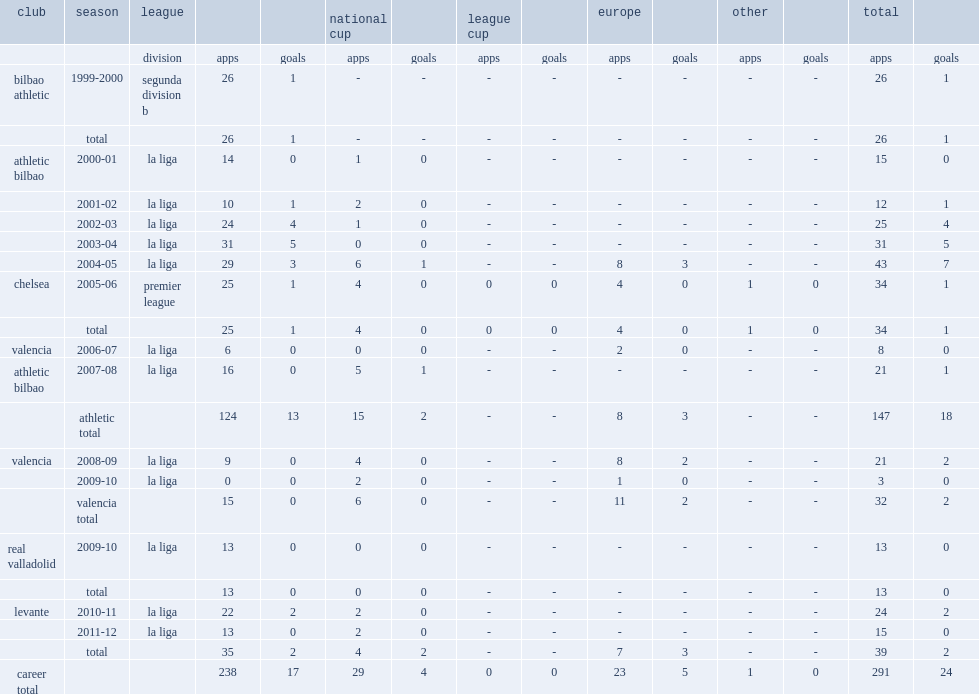How many goals did asier del horno score for athletic bilbao. 17. 